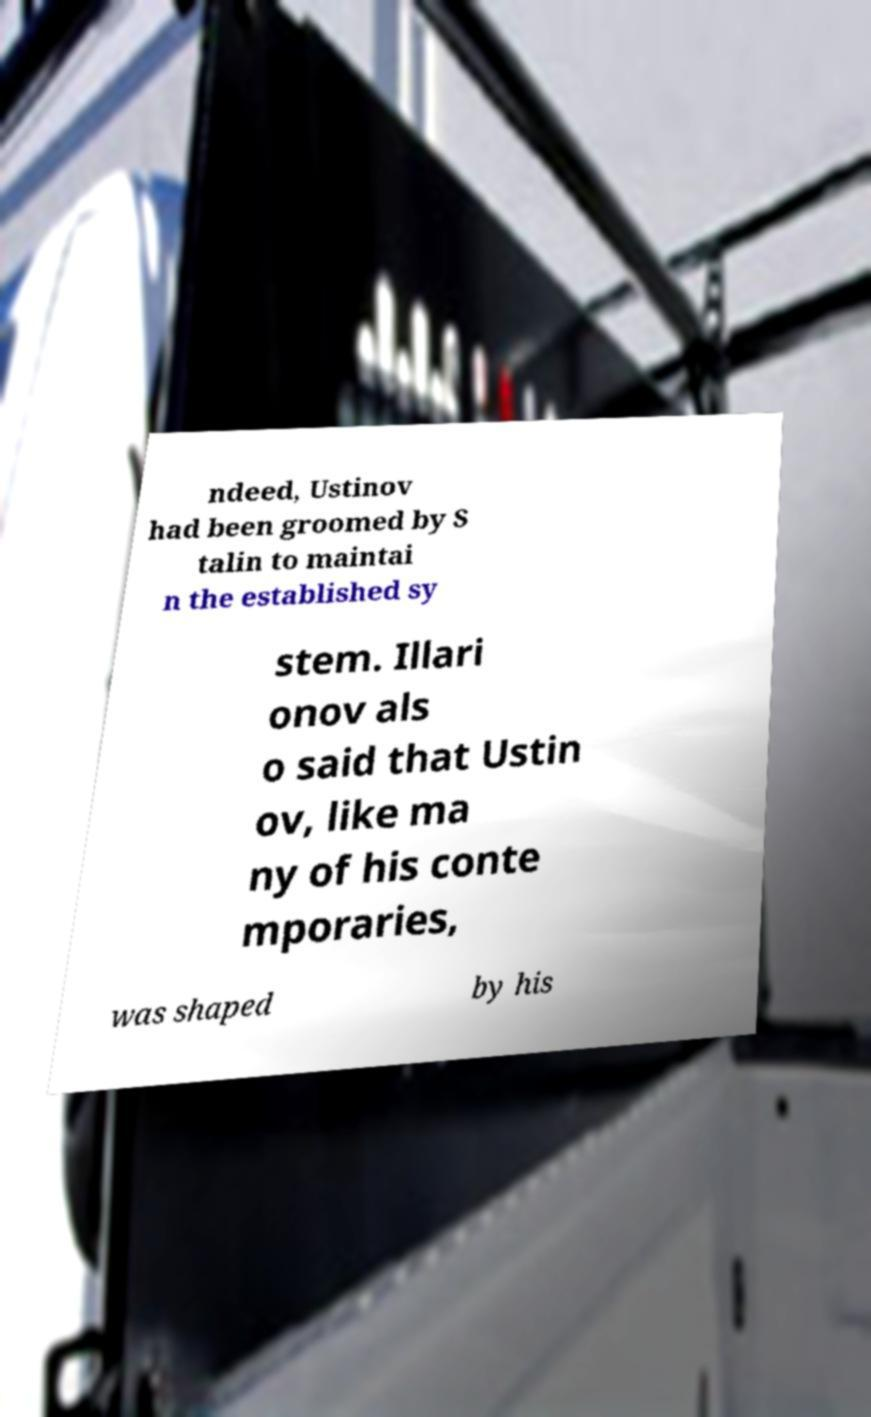Can you accurately transcribe the text from the provided image for me? ndeed, Ustinov had been groomed by S talin to maintai n the established sy stem. Illari onov als o said that Ustin ov, like ma ny of his conte mporaries, was shaped by his 